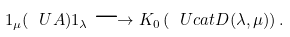<formula> <loc_0><loc_0><loc_500><loc_500>1 _ { \mu } ( \ U A ) 1 _ { \lambda } \longrightarrow K _ { 0 } \left ( \ U c a t D ( \lambda , \mu ) \right ) .</formula> 